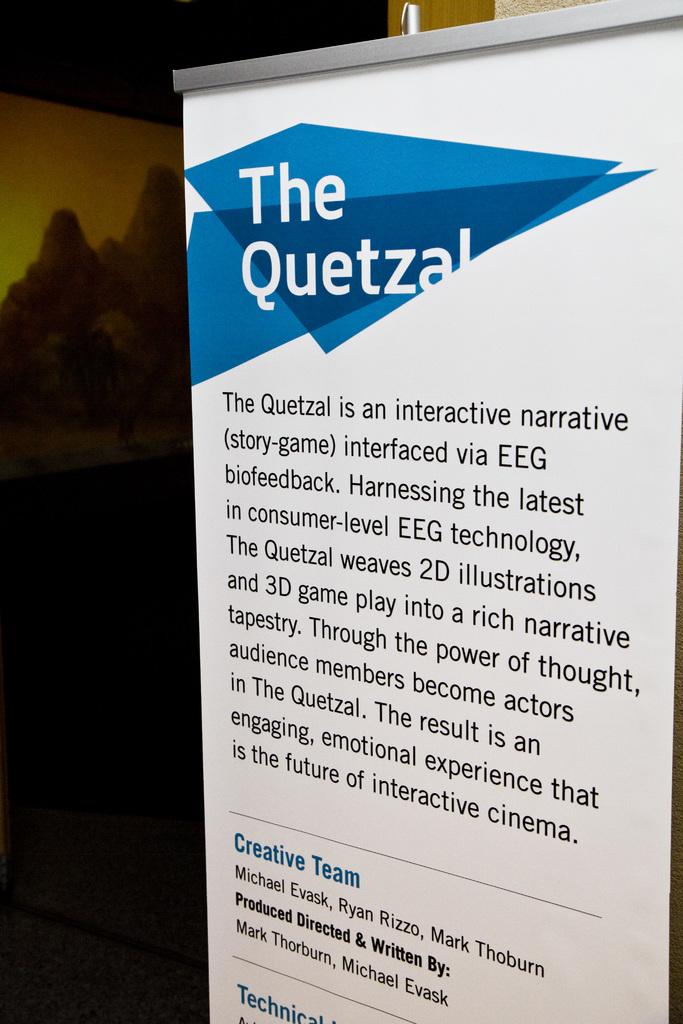What is the quetzal?
Your answer should be very brief. Interactive narrative interfaced via eeg biofeedback. Who was the pamphlet written by?
Your response must be concise. Mark thorburn, michael evask. 